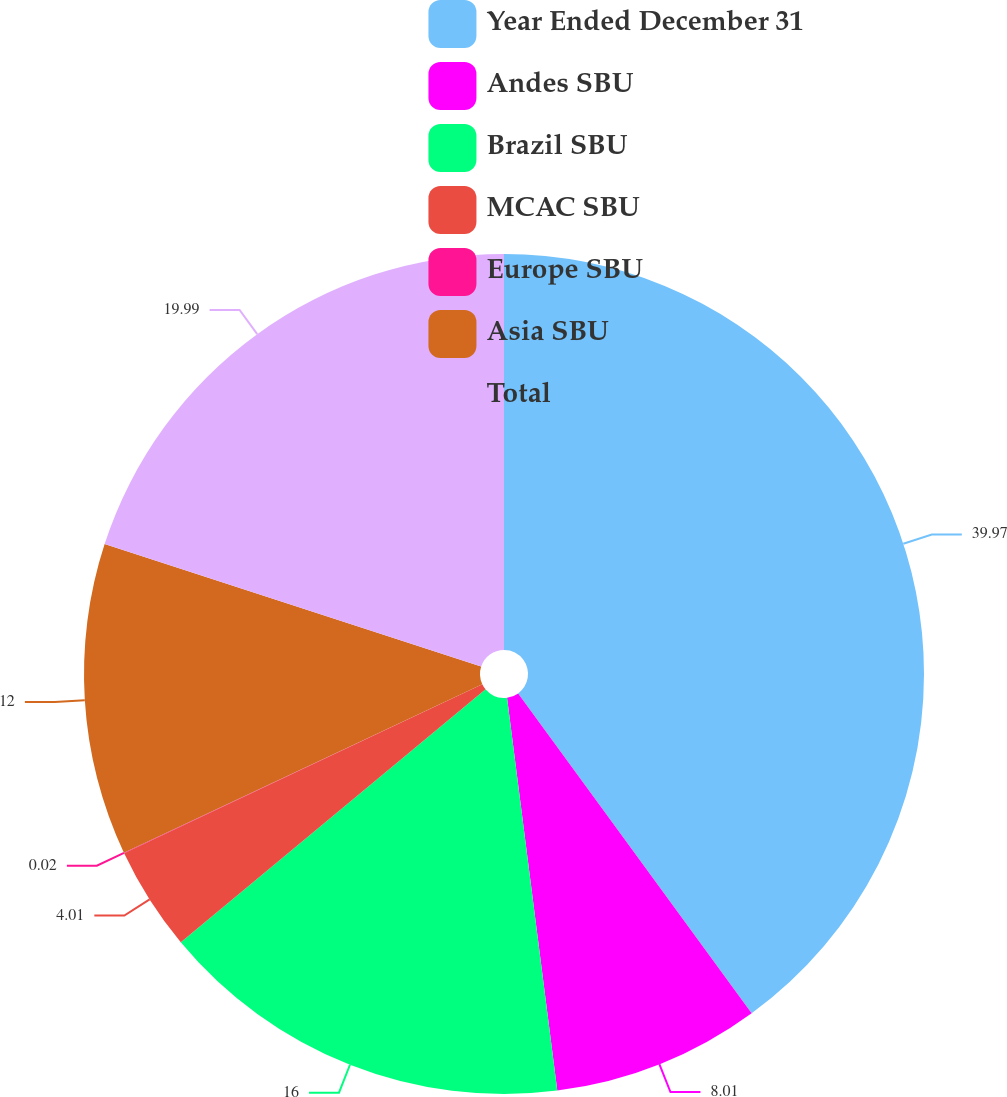Convert chart. <chart><loc_0><loc_0><loc_500><loc_500><pie_chart><fcel>Year Ended December 31<fcel>Andes SBU<fcel>Brazil SBU<fcel>MCAC SBU<fcel>Europe SBU<fcel>Asia SBU<fcel>Total<nl><fcel>39.96%<fcel>8.01%<fcel>16.0%<fcel>4.01%<fcel>0.02%<fcel>12.0%<fcel>19.99%<nl></chart> 